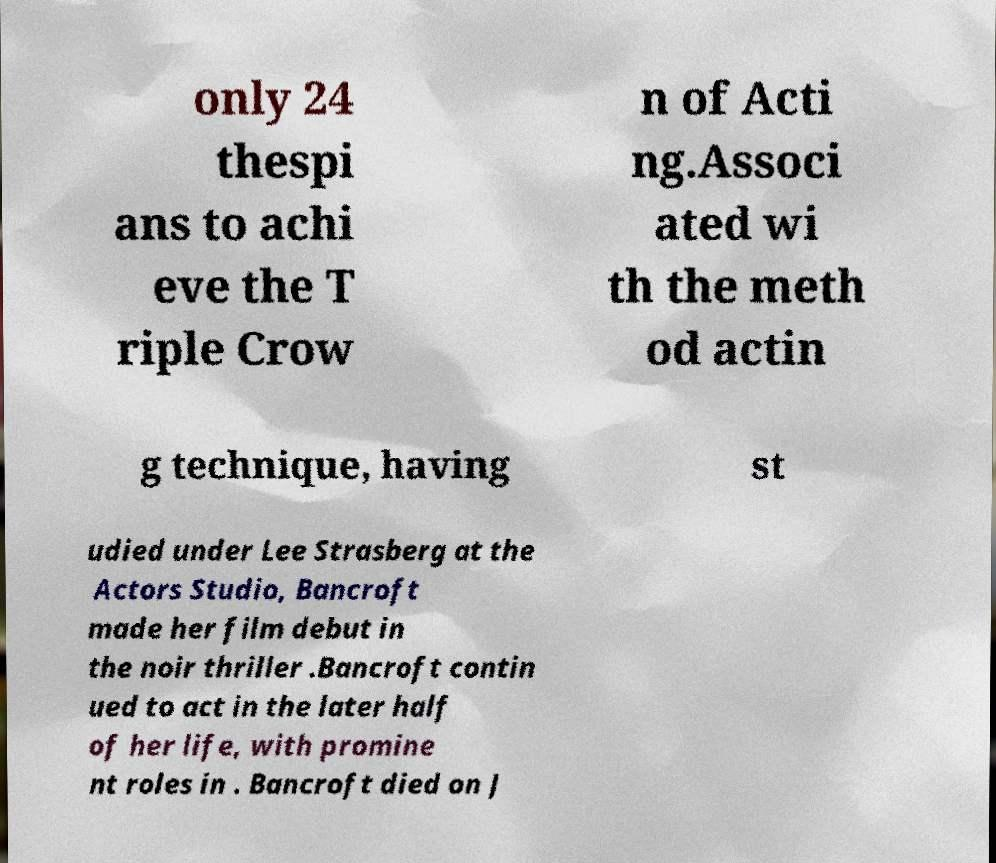Could you extract and type out the text from this image? only 24 thespi ans to achi eve the T riple Crow n of Acti ng.Associ ated wi th the meth od actin g technique, having st udied under Lee Strasberg at the Actors Studio, Bancroft made her film debut in the noir thriller .Bancroft contin ued to act in the later half of her life, with promine nt roles in . Bancroft died on J 